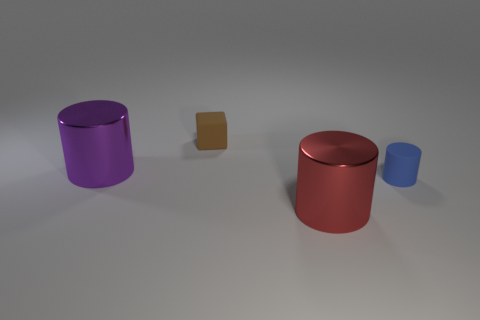What number of other tiny cylinders have the same color as the small cylinder?
Your answer should be compact. 0. Is the material of the small object in front of the small cube the same as the tiny block?
Give a very brief answer. Yes. What number of tiny blue things are made of the same material as the brown block?
Ensure brevity in your answer.  1. Are there more matte objects on the right side of the tiny brown object than big brown matte spheres?
Offer a very short reply. Yes. Are there any small blue things that have the same shape as the red thing?
Give a very brief answer. Yes. How many objects are either blue rubber objects or big metal things?
Provide a succinct answer. 3. There is a matte object that is in front of the shiny thing behind the large red metal thing; how many purple shiny things are to the right of it?
Give a very brief answer. 0. What material is the blue object that is the same shape as the big purple metal object?
Your response must be concise. Rubber. What is the thing that is both behind the small blue matte cylinder and in front of the tiny brown rubber object made of?
Offer a very short reply. Metal. Is the number of blue cylinders behind the purple cylinder less than the number of things on the left side of the brown block?
Offer a very short reply. Yes. 